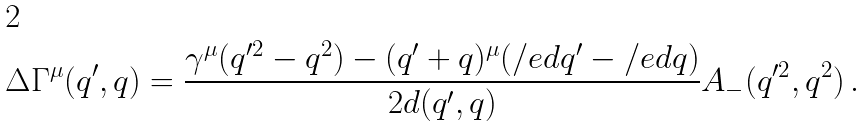<formula> <loc_0><loc_0><loc_500><loc_500>\Delta \Gamma ^ { \mu } ( q ^ { \prime } , q ) = \frac { \gamma ^ { \mu } ( q ^ { \prime 2 } - q ^ { 2 } ) - ( q ^ { \prime } + q ) ^ { \mu } ( \slash e d { q } ^ { \prime } - \slash e d { q } ) } { 2 d ( q ^ { \prime } , q ) } { A _ { - } ( q ^ { \prime 2 } , q ^ { 2 } ) } \, .</formula> 